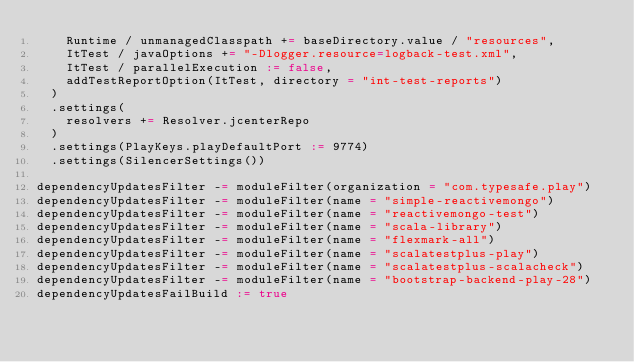<code> <loc_0><loc_0><loc_500><loc_500><_Scala_>    Runtime / unmanagedClasspath += baseDirectory.value / "resources",
    ItTest / javaOptions += "-Dlogger.resource=logback-test.xml",
    ItTest / parallelExecution := false,
    addTestReportOption(ItTest, directory = "int-test-reports")
  )
  .settings(
    resolvers += Resolver.jcenterRepo
  )
  .settings(PlayKeys.playDefaultPort := 9774)
  .settings(SilencerSettings())

dependencyUpdatesFilter -= moduleFilter(organization = "com.typesafe.play")
dependencyUpdatesFilter -= moduleFilter(name = "simple-reactivemongo")
dependencyUpdatesFilter -= moduleFilter(name = "reactivemongo-test")
dependencyUpdatesFilter -= moduleFilter(name = "scala-library")
dependencyUpdatesFilter -= moduleFilter(name = "flexmark-all")
dependencyUpdatesFilter -= moduleFilter(name = "scalatestplus-play")
dependencyUpdatesFilter -= moduleFilter(name = "scalatestplus-scalacheck")
dependencyUpdatesFilter -= moduleFilter(name = "bootstrap-backend-play-28")
dependencyUpdatesFailBuild := true
</code> 